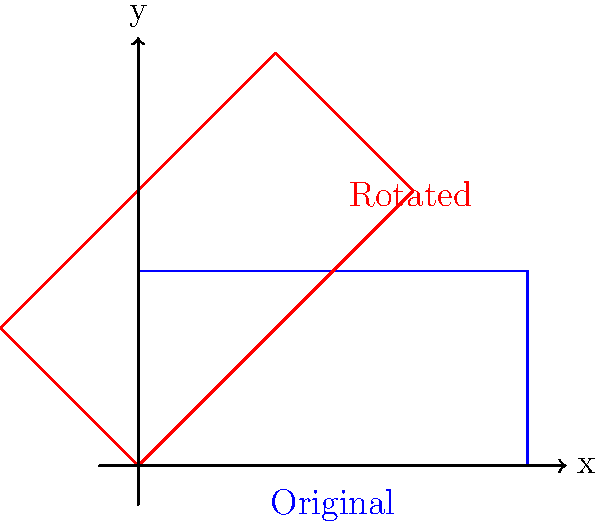As a tennis coach, you're explaining court positioning using a diagram. The original tennis court is represented by a blue rectangle, and you want to rotate it to match the red rectangle's orientation. What is the angle of rotation (in degrees) needed to transform the blue court into the position of the red court? To solve this problem, we'll follow these steps:

1. Observe the diagram: The blue rectangle represents the original tennis court, and the red rectangle shows the rotated position.

2. Identify the rotation: The rotation appears to be counterclockwise around the origin (0,0).

3. Determine the angle: In geometry, a 45-degree angle is easily recognizable as it forms an equal angle with both the x and y axes. The rotated court (red) clearly exhibits this characteristic.

4. Verify the rotation: If we mentally rotate the blue rectangle by 45 degrees counterclockwise, it would align perfectly with the red rectangle.

5. Consider the aviation history aspect: As an aviation enthusiast, you might relate this to aircraft navigation, where a 45-degree turn is a common maneuver, often referred to as a "diagonal" or "intercept" heading.

Therefore, the angle of rotation needed to transform the blue court into the position of the red court is 45 degrees counterclockwise.
Answer: 45° 